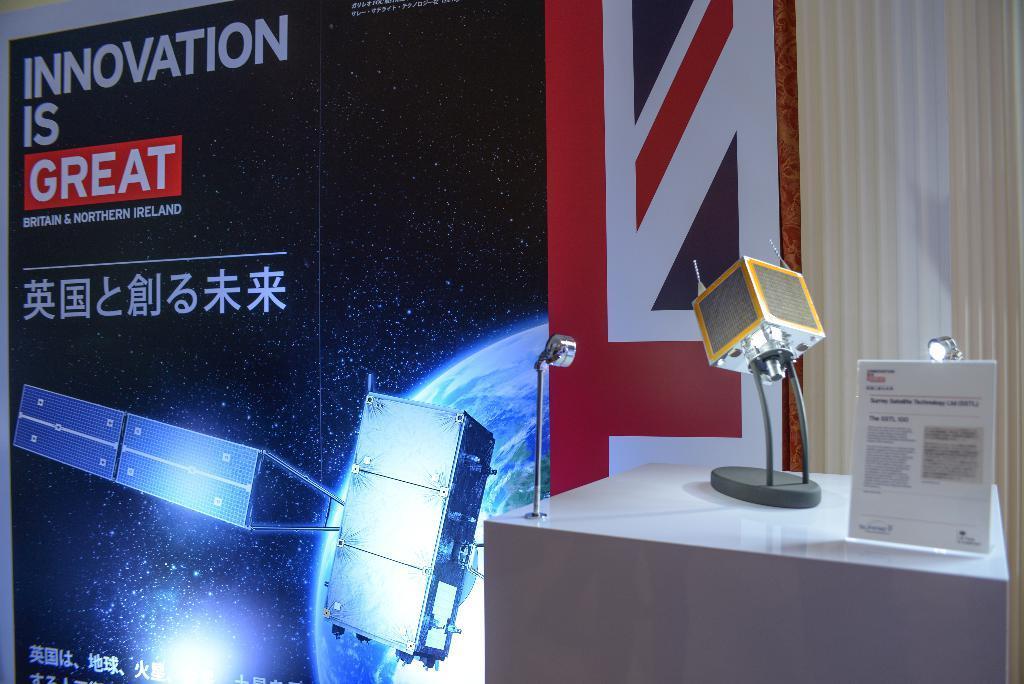Could you give a brief overview of what you see in this image? This picture is clicked inside. On the left we can see a banner on which we can see the picture of some objects and we can see the text on the banner. On the right there is a table on the top of which some items are placed. In the background there is a white color object seems to be a curtain. 